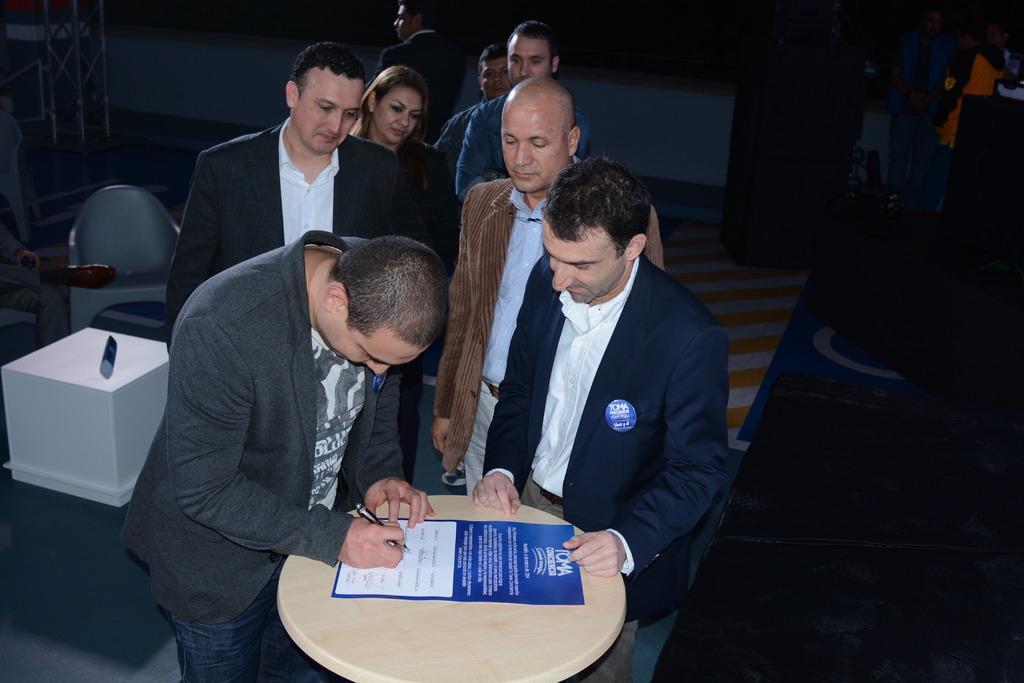Can you describe this image briefly? In the image we can see that, there are many people standing, this is a table on which a sheet of paper is their. This man is holding a pen in his hand. 